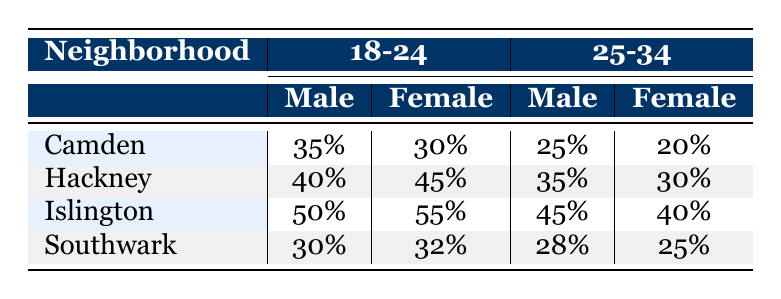What is the participation rate for males aged 18-24 in Camden? In the table, I can look under the "Camden" row and the age group "18-24" for males. The participation rate is 35%.
Answer: 35% Which neighborhood has the highest participation rate for females in the 25-34 age group? I need to check the participation rates for females in the "25-34" age group. Islington has a participation rate of 40%, which is higher than Camden's 20%, Hackney's 30%, and Southwark's 25%.
Answer: Islington What is the average participation rate for males across all neighborhoods in the 25-34 age group? To find the average, I first add the participation rates for males in the 25-34 age group: Camden (25) + Hackney (35) + Islington (45) + Southwark (28) = 133. Then, I divide by the number of neighborhoods (4), which gives 133/4 = 33.25.
Answer: 33.25 Is the participation rate for females in Hackney aged 18-24 greater than that in Camden? I compare the participation rates for females aged 18-24 in both neighborhoods. Hackney has a rate of 45%, while Camden has 30%. Since 45% is greater than 30%, the statement is true.
Answer: Yes Which age group has a higher overall participation rate for males: 18-24 or 25-34? For males, I need to sum the participation rates for each age group. For 18-24: Camden (35) + Hackney (40) + Islington (50) + Southwark (30) = 155. For 25-34: Camden (25) + Hackney (35) + Islington (45) + Southwark (28) = 133. Since 155 is greater than 133, 18-24 has a higher rate.
Answer: 18-24 Do females in Southwark aged 18-24 have a higher participation rate than those in Islington? I compare the rates: females aged 18-24 in Southwark have a participation rate of 32%, while in Islington it is 55%. Since 32% is less than 55%, the statement is false.
Answer: No 